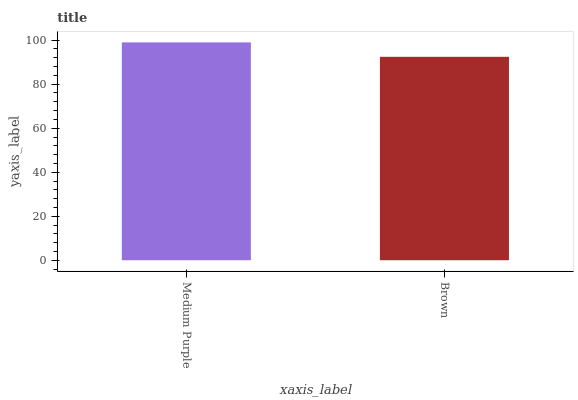Is Brown the minimum?
Answer yes or no. Yes. Is Medium Purple the maximum?
Answer yes or no. Yes. Is Brown the maximum?
Answer yes or no. No. Is Medium Purple greater than Brown?
Answer yes or no. Yes. Is Brown less than Medium Purple?
Answer yes or no. Yes. Is Brown greater than Medium Purple?
Answer yes or no. No. Is Medium Purple less than Brown?
Answer yes or no. No. Is Medium Purple the high median?
Answer yes or no. Yes. Is Brown the low median?
Answer yes or no. Yes. Is Brown the high median?
Answer yes or no. No. Is Medium Purple the low median?
Answer yes or no. No. 